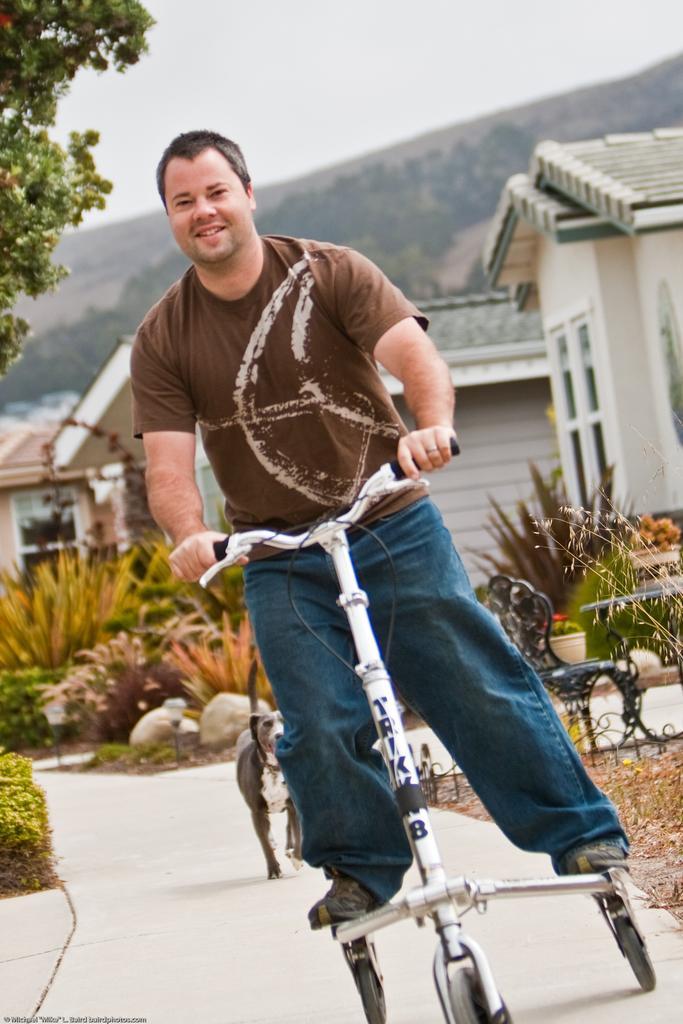Could you give a brief overview of what you see in this image? In this image there is a person riding some some vehicle, behind him there is a dog, plants and building. 